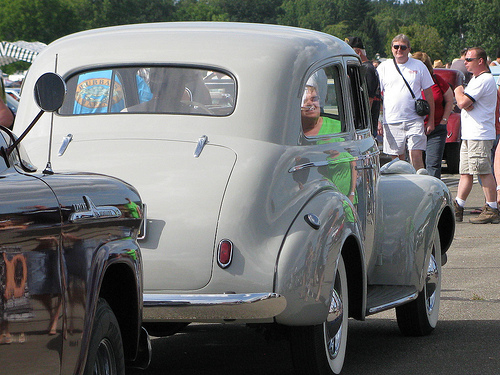<image>
Is the wheel on the car? No. The wheel is not positioned on the car. They may be near each other, but the wheel is not supported by or resting on top of the car. 